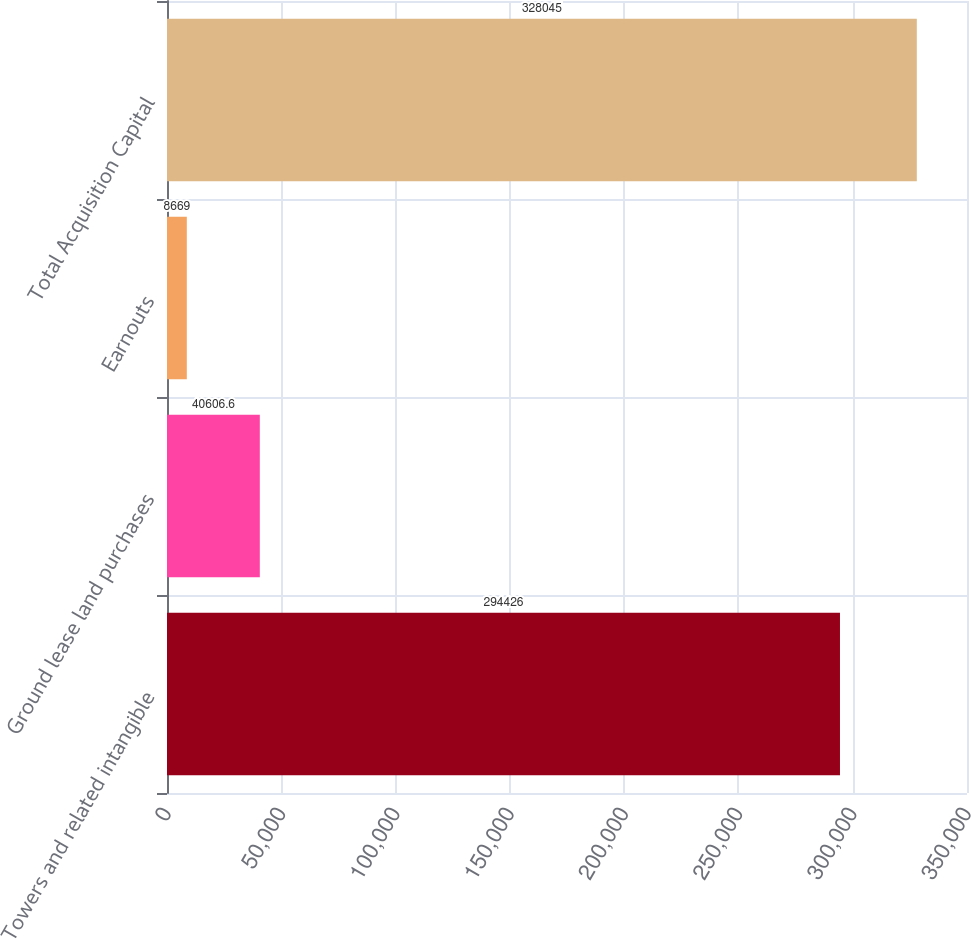Convert chart. <chart><loc_0><loc_0><loc_500><loc_500><bar_chart><fcel>Towers and related intangible<fcel>Ground lease land purchases<fcel>Earnouts<fcel>Total Acquisition Capital<nl><fcel>294426<fcel>40606.6<fcel>8669<fcel>328045<nl></chart> 